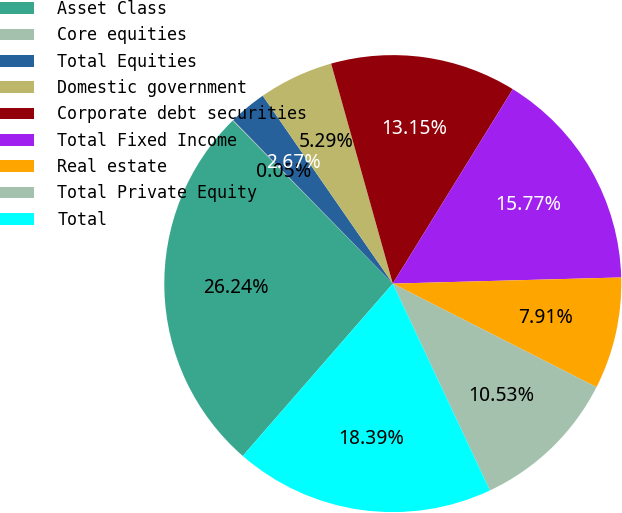<chart> <loc_0><loc_0><loc_500><loc_500><pie_chart><fcel>Asset Class<fcel>Core equities<fcel>Total Equities<fcel>Domestic government<fcel>Corporate debt securities<fcel>Total Fixed Income<fcel>Real estate<fcel>Total Private Equity<fcel>Total<nl><fcel>26.24%<fcel>0.05%<fcel>2.67%<fcel>5.29%<fcel>13.15%<fcel>15.77%<fcel>7.91%<fcel>10.53%<fcel>18.39%<nl></chart> 